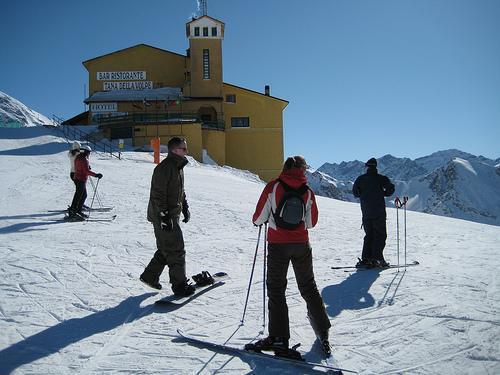How many people have snowboards?
Give a very brief answer. 1. How many people are in the photo?
Give a very brief answer. 3. 